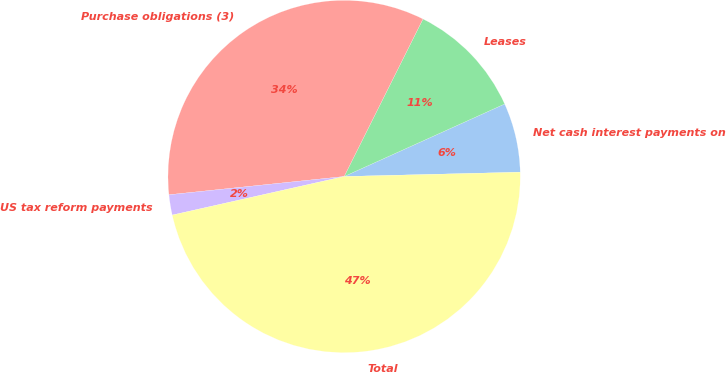<chart> <loc_0><loc_0><loc_500><loc_500><pie_chart><fcel>Net cash interest payments on<fcel>Leases<fcel>Purchase obligations (3)<fcel>US tax reform payments<fcel>Total<nl><fcel>6.36%<fcel>10.86%<fcel>34.04%<fcel>1.86%<fcel>46.88%<nl></chart> 